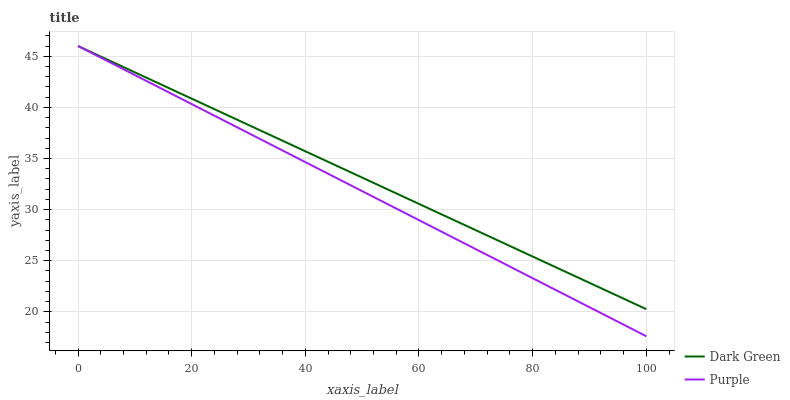Does Purple have the minimum area under the curve?
Answer yes or no. Yes. Does Dark Green have the maximum area under the curve?
Answer yes or no. Yes. Does Dark Green have the minimum area under the curve?
Answer yes or no. No. Is Purple the smoothest?
Answer yes or no. Yes. Is Dark Green the roughest?
Answer yes or no. Yes. Is Dark Green the smoothest?
Answer yes or no. No. Does Purple have the lowest value?
Answer yes or no. Yes. Does Dark Green have the lowest value?
Answer yes or no. No. Does Dark Green have the highest value?
Answer yes or no. Yes. Does Dark Green intersect Purple?
Answer yes or no. Yes. Is Dark Green less than Purple?
Answer yes or no. No. Is Dark Green greater than Purple?
Answer yes or no. No. 